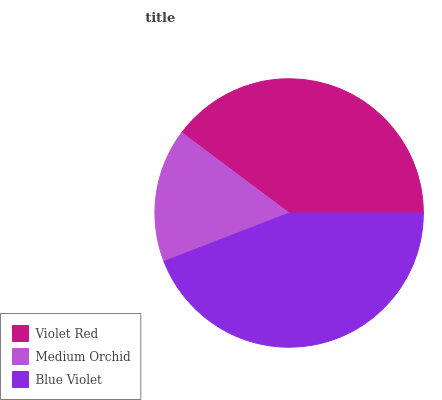Is Medium Orchid the minimum?
Answer yes or no. Yes. Is Blue Violet the maximum?
Answer yes or no. Yes. Is Blue Violet the minimum?
Answer yes or no. No. Is Medium Orchid the maximum?
Answer yes or no. No. Is Blue Violet greater than Medium Orchid?
Answer yes or no. Yes. Is Medium Orchid less than Blue Violet?
Answer yes or no. Yes. Is Medium Orchid greater than Blue Violet?
Answer yes or no. No. Is Blue Violet less than Medium Orchid?
Answer yes or no. No. Is Violet Red the high median?
Answer yes or no. Yes. Is Violet Red the low median?
Answer yes or no. Yes. Is Medium Orchid the high median?
Answer yes or no. No. Is Blue Violet the low median?
Answer yes or no. No. 